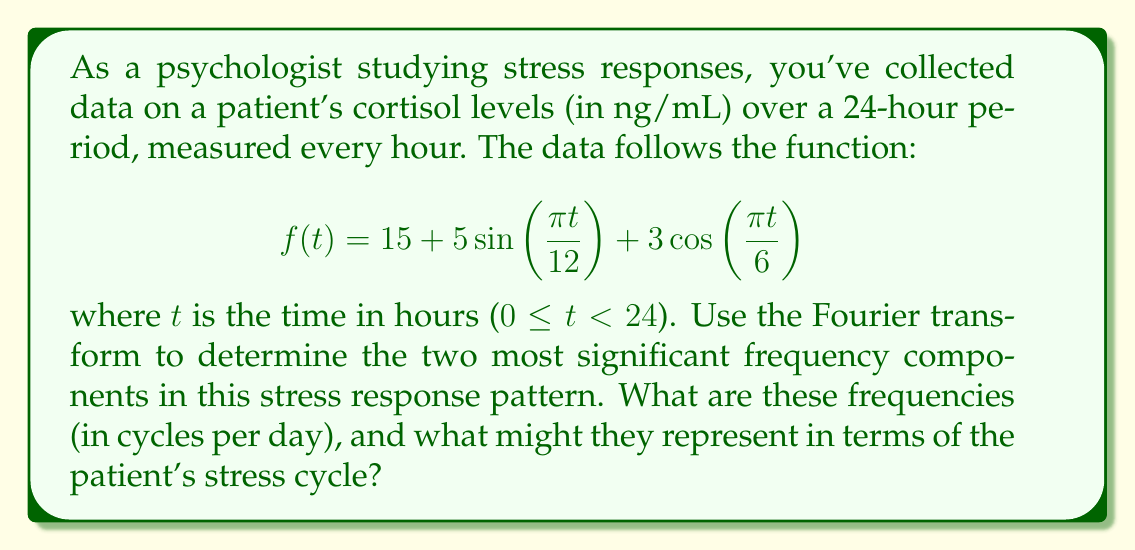Provide a solution to this math problem. To solve this problem, we'll follow these steps:

1) First, we need to identify the frequency components in the given function. The Fourier transform isn't necessary here because the function is already expressed as a sum of sinusoids.

2) In the function $f(t) = 15 + 5\sin(\frac{\pi t}{12}) + 3\cos(\frac{\pi t}{6})$, we have:
   
   - A constant term (15)
   - A sine term with frequency $\frac{\pi}{12}$
   - A cosine term with frequency $\frac{\pi}{6}$

3) To convert these angular frequencies to cycles per day, we use the formula:

   $$\text{frequency (cycles/day)} = \frac{\text{angular frequency}}{2\pi} \cdot 24 \text{ hours/day}$$

4) For the sine term:
   $$\frac{\frac{\pi}{12}}{2\pi} \cdot 24 = 1 \text{ cycle/day}$$

5) For the cosine term:
   $$\frac{\frac{\pi}{6}}{2\pi} \cdot 24 = 2 \text{ cycles/day}$$

6) The amplitudes of these components are 5 for the 1 cycle/day component and 3 for the 2 cycles/day component.

7) Therefore, the two most significant frequency components are 1 cycle/day (the stronger of the two) and 2 cycles/day.

8) In terms of the patient's stress cycle:
   - The 1 cycle/day component likely represents the daily (circadian) rhythm of cortisol, which typically peaks in the morning and drops in the evening.
   - The 2 cycles/day component might represent a bi-phasic pattern, possibly related to meal times or work shifts.
Answer: The two most significant frequency components are 1 cycle/day and 2 cycles/day. These likely represent the patient's daily circadian rhythm and a bi-phasic pattern in cortisol levels, respectively. 